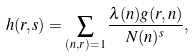<formula> <loc_0><loc_0><loc_500><loc_500>h ( r , s ) = \sum _ { ( n , r ) = 1 } \frac { \lambda ( n ) g ( r , n ) } { N ( n ) ^ { s } } ,</formula> 